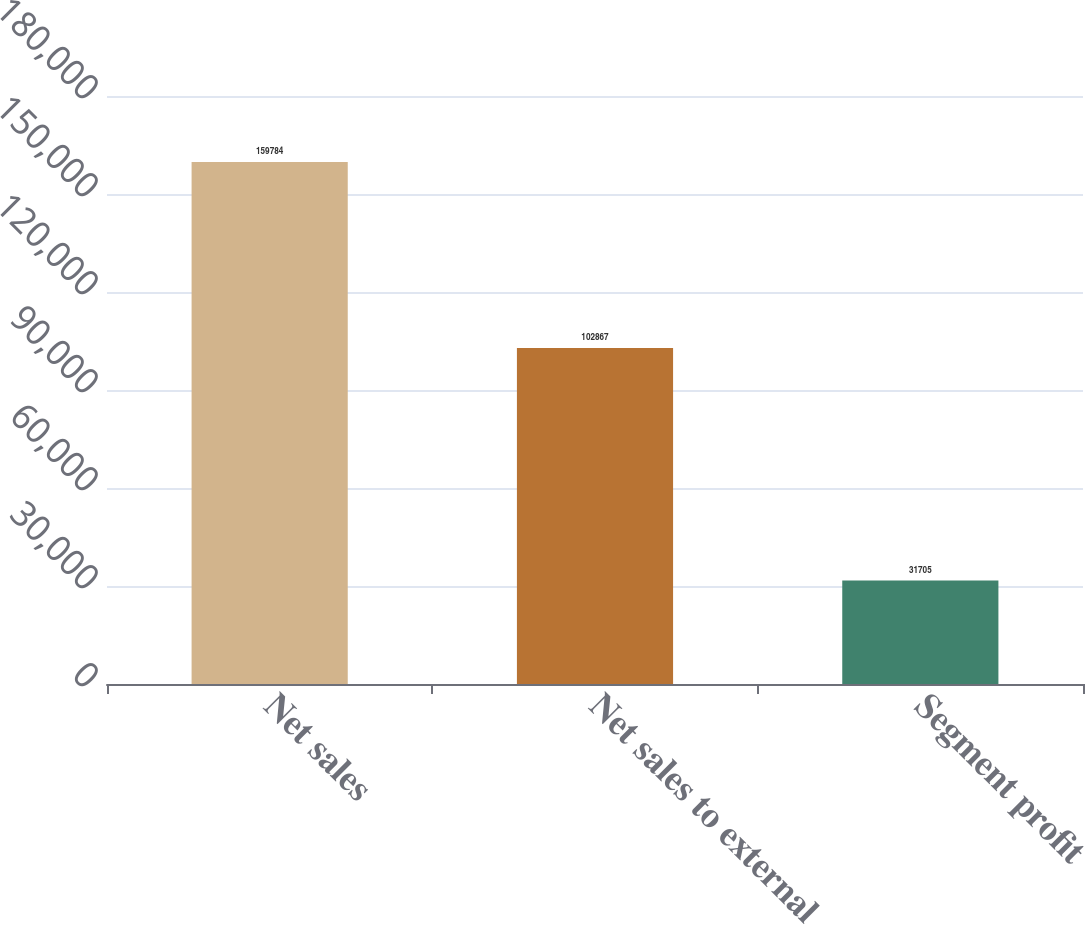<chart> <loc_0><loc_0><loc_500><loc_500><bar_chart><fcel>Net sales<fcel>Net sales to external<fcel>Segment profit<nl><fcel>159784<fcel>102867<fcel>31705<nl></chart> 